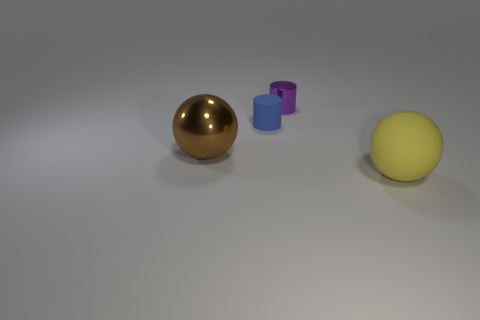How many other objects have the same material as the brown object?
Offer a terse response. 1. There is a yellow matte thing that is the same shape as the brown object; what is its size?
Give a very brief answer. Large. Do the big object that is to the left of the large rubber ball and the yellow object have the same shape?
Give a very brief answer. Yes. The large object left of the metal object that is behind the big brown shiny thing is what shape?
Keep it short and to the point. Sphere. Is there anything else that has the same shape as the tiny rubber thing?
Keep it short and to the point. Yes. There is another object that is the same shape as the tiny blue rubber object; what is its color?
Offer a very short reply. Purple. Do the metal sphere and the matte thing on the left side of the large yellow sphere have the same color?
Make the answer very short. No. There is a thing that is both in front of the tiny matte cylinder and to the right of the brown ball; what shape is it?
Provide a succinct answer. Sphere. Are there fewer large yellow objects than tiny gray matte blocks?
Provide a succinct answer. No. Are any small yellow rubber blocks visible?
Ensure brevity in your answer.  No. 